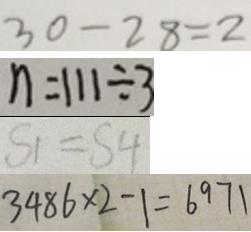<formula> <loc_0><loc_0><loc_500><loc_500>3 0 - 2 8 = 2 
 n = 1 1 1 \div 3 
 S _ { 1 } = S _ { 4 } 
 2 4 8 6 \times 2 - 1 = 6 9 7 1</formula> 